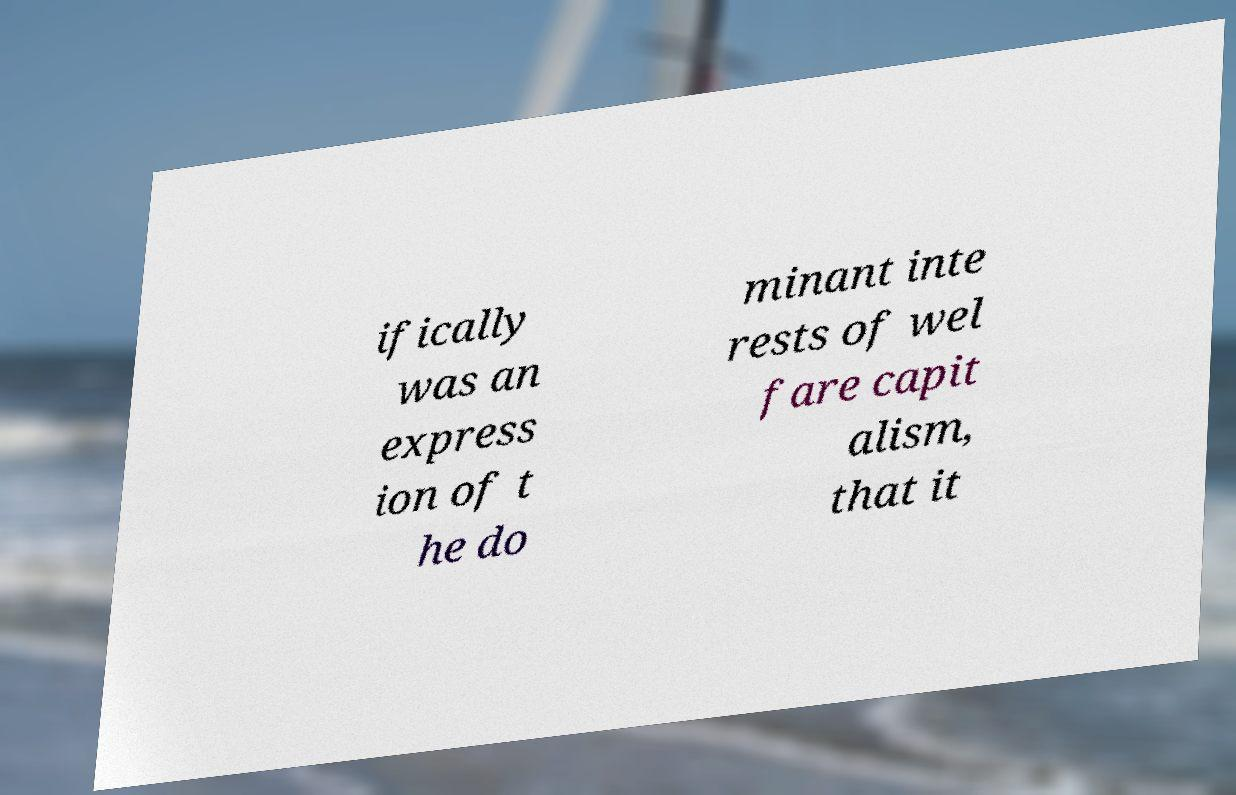Please identify and transcribe the text found in this image. ifically was an express ion of t he do minant inte rests of wel fare capit alism, that it 